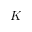Convert formula to latex. <formula><loc_0><loc_0><loc_500><loc_500>K _ { - }</formula> 